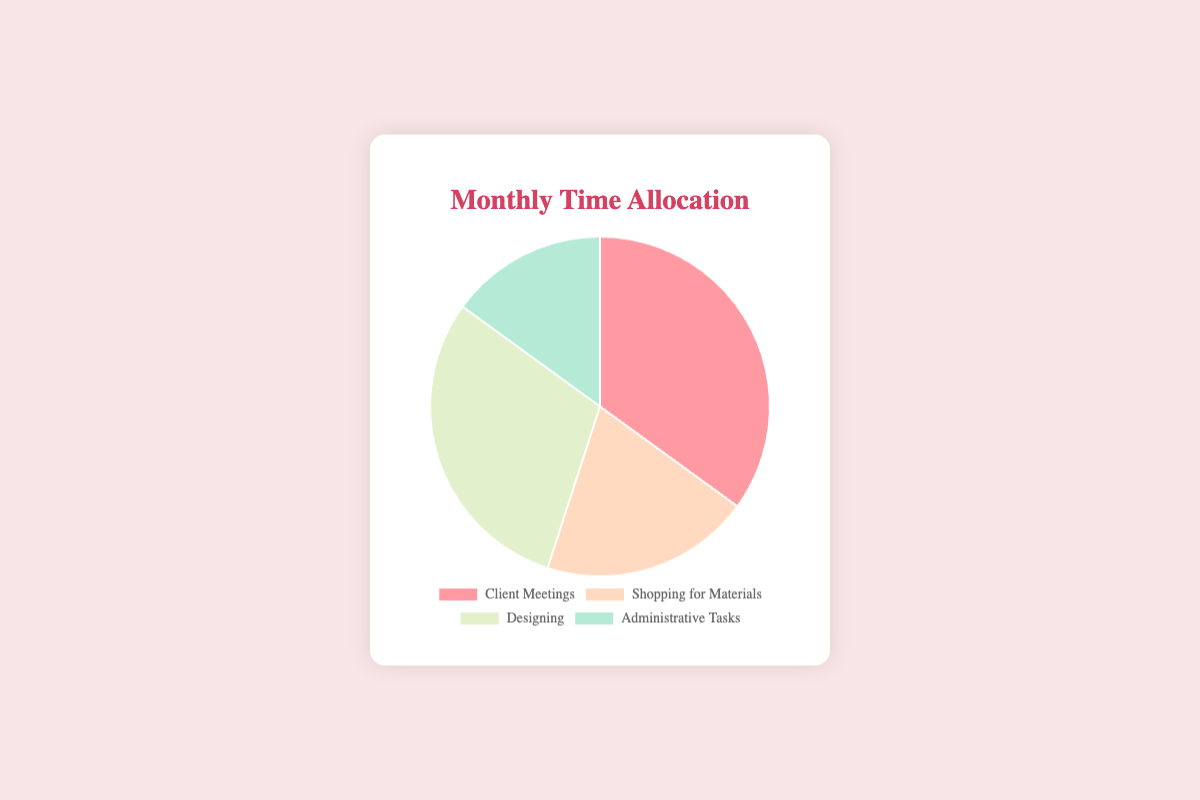What's the largest time allocation category? The segment with the largest percentage indicates the category with the most time allocated. By observing the pie chart, we see that "Client Meetings" has the largest segment.
Answer: Client Meetings Which activity has the smallest time allocation? The segment with the smallest percentage represents the activity with the least time allocated. By reviewing the pie chart, we see that "Administrative Tasks" has the smallest segment.
Answer: Administrative Tasks How much more time is spent on Designing than on Shopping for Materials? To determine this, subtract the percentage allocated for "Shopping for Materials" from that for "Designing": 30% - 20% = 10%.
Answer: 10% If you combine the time spent on Client Meetings and Administrative Tasks, what percentage do you get? Add the percentages for "Client Meetings" and "Administrative Tasks": 35% + 15% = 50%.
Answer: 50% Between Shopping for Materials and Designing, which activity gets more time, and by how much? Compare the percentages and subtract: "Designing" gets 30% and "Shopping for Materials" gets 20%. The difference is 30% - 20% = 10%.
Answer: Designing, by 10% What percentage of your time is spent on non-administrative tasks? Add the percentages of Client Meetings, Shopping for Materials, and Designing and subtract from 100%: 100% - 15% = 85%.
Answer: 85% What are the colors used to represent Client Meetings and Designing in the chart? The colors are visually identifiable segments: pink for "Client Meetings" and light green for "Designing".
Answer: pink, light green Which two categories together make up half of your monthly time allocation? Look for two categories whose combined percentage equals 50%. "Client Meetings" and "Administrative Tasks" add up to 50% (35% + 15%).
Answer: Client Meetings and Administrative Tasks If you want to evenly distribute your time across all four activities, how would you allocate it? Equal distribution means 25% for each category since 100% ÷ 4 = 25%.
Answer: 25% each 